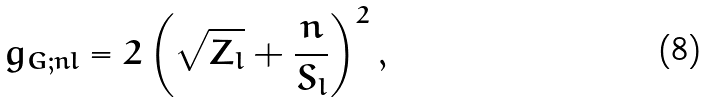<formula> <loc_0><loc_0><loc_500><loc_500>g _ { G ; n l } = 2 \left ( \sqrt { Z _ { l } } + \frac { n } { S _ { l } } \right ) ^ { 2 } ,</formula> 